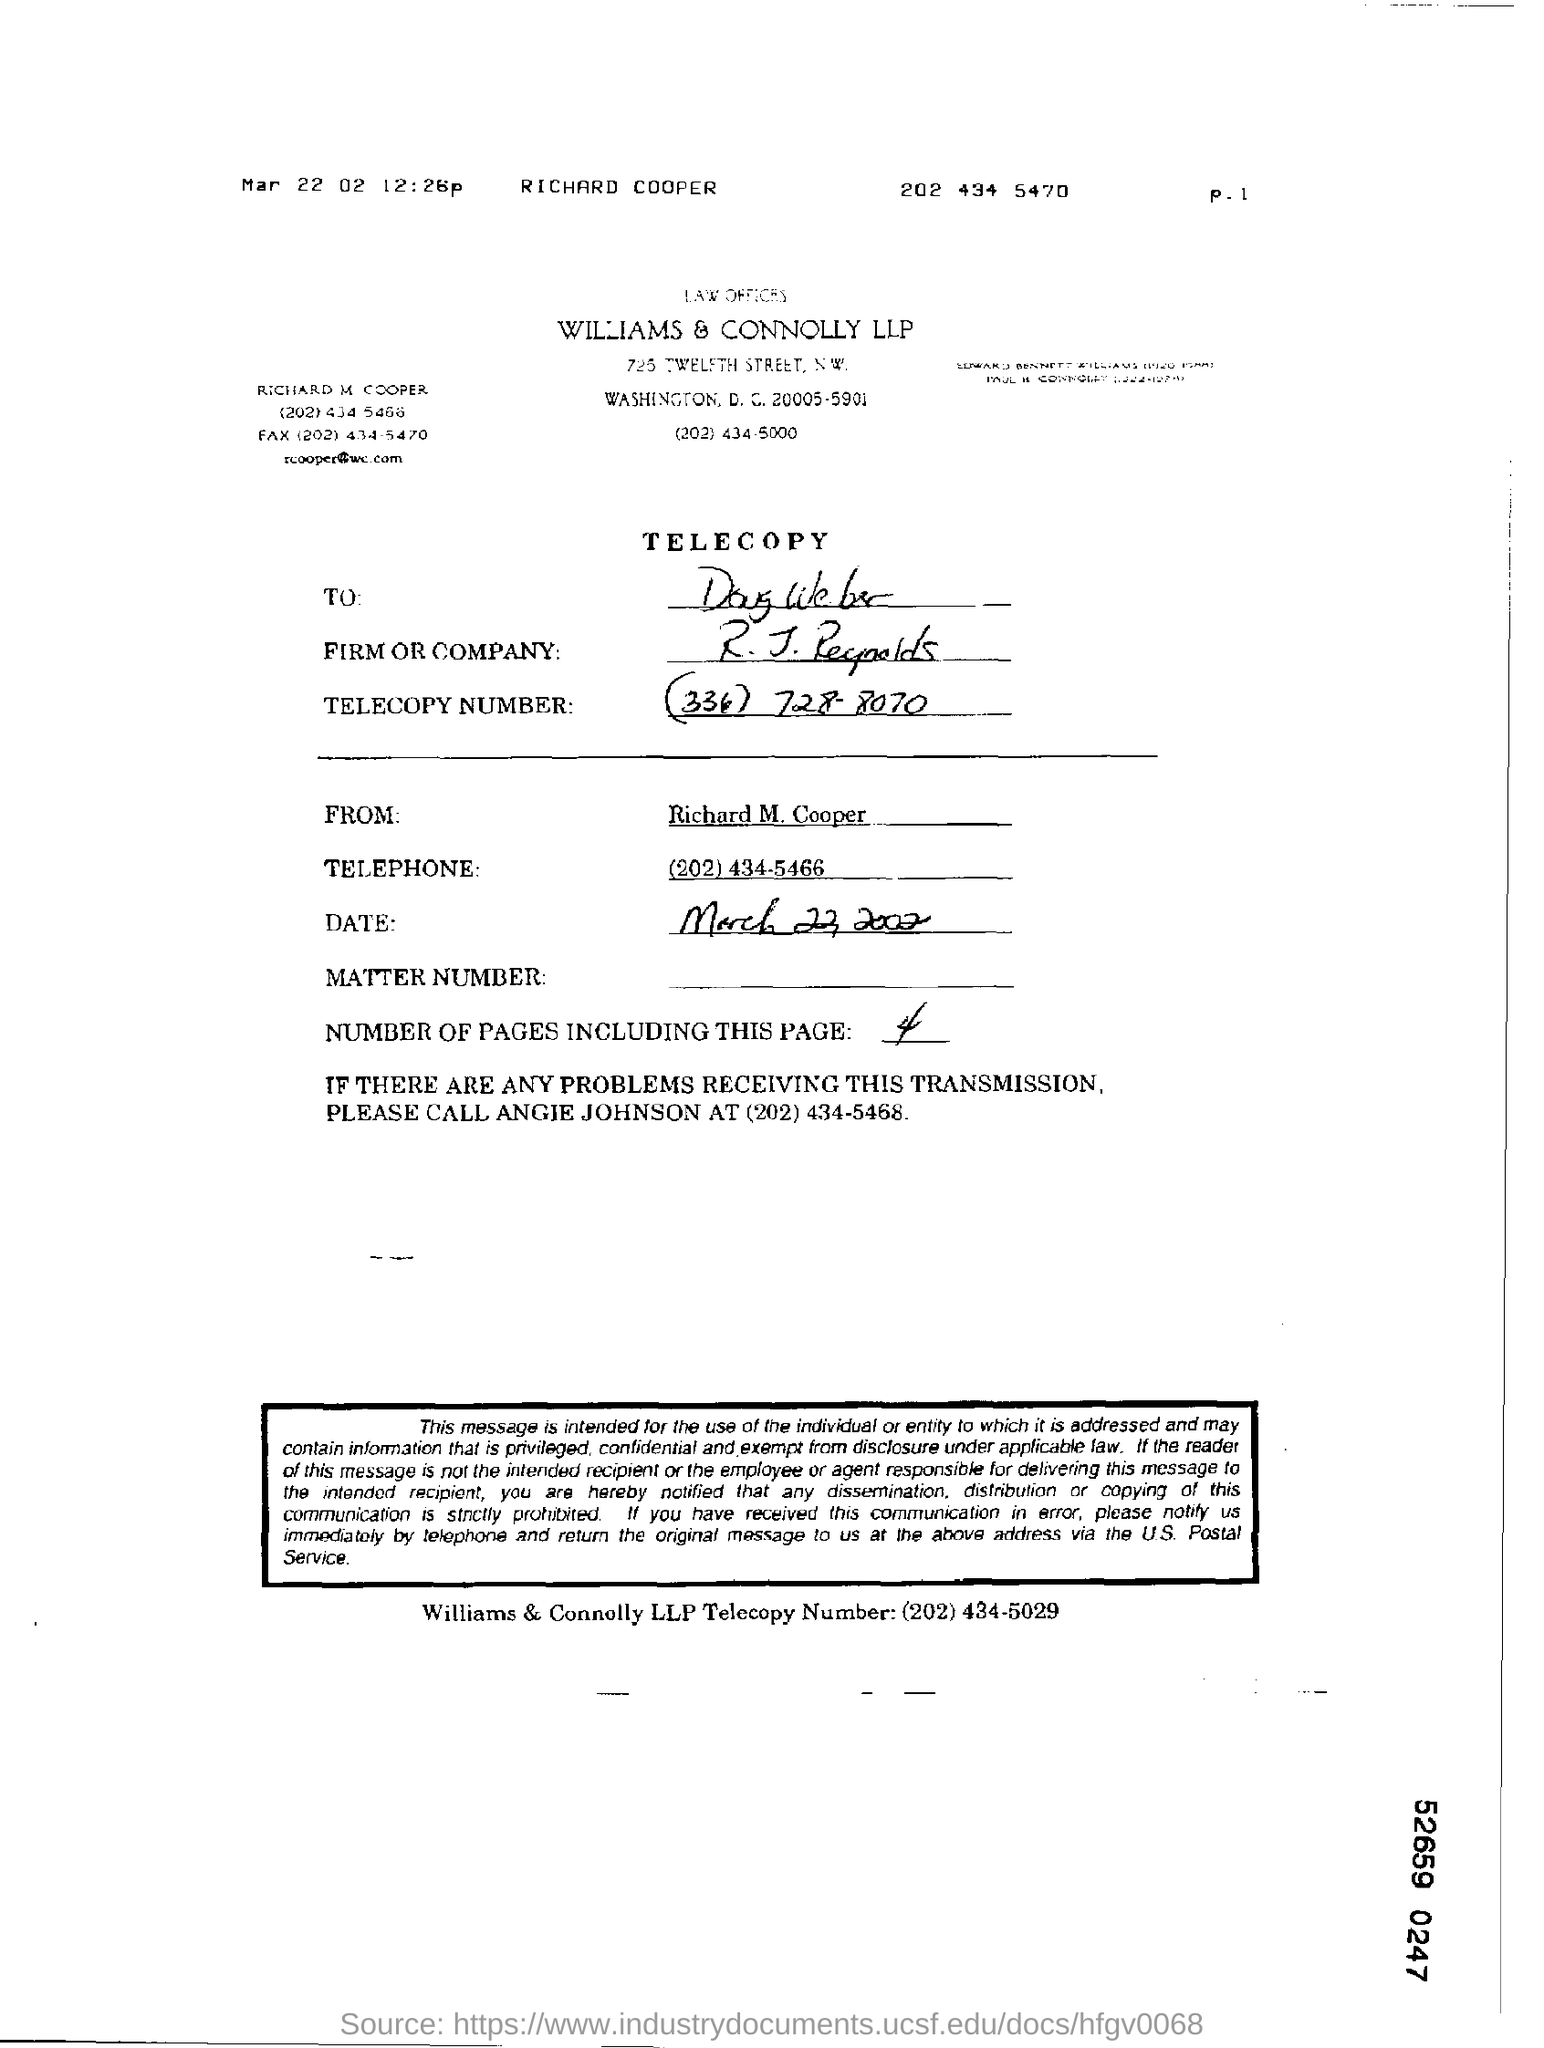Mention a couple of crucial points in this snapshot. The telecopy message is from Richard M. Cooper. The telecopy number is (334) 728-8070. This telecopy is addressed to Doug Weber. 